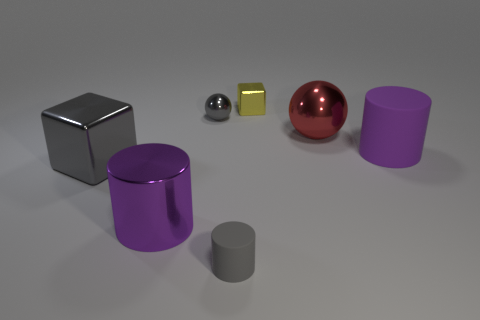Add 2 metal objects. How many objects exist? 9 Subtract all spheres. How many objects are left? 5 Add 6 yellow metallic things. How many yellow metallic things exist? 7 Subtract 1 gray spheres. How many objects are left? 6 Subtract all big purple rubber objects. Subtract all rubber things. How many objects are left? 4 Add 5 big metallic cylinders. How many big metallic cylinders are left? 6 